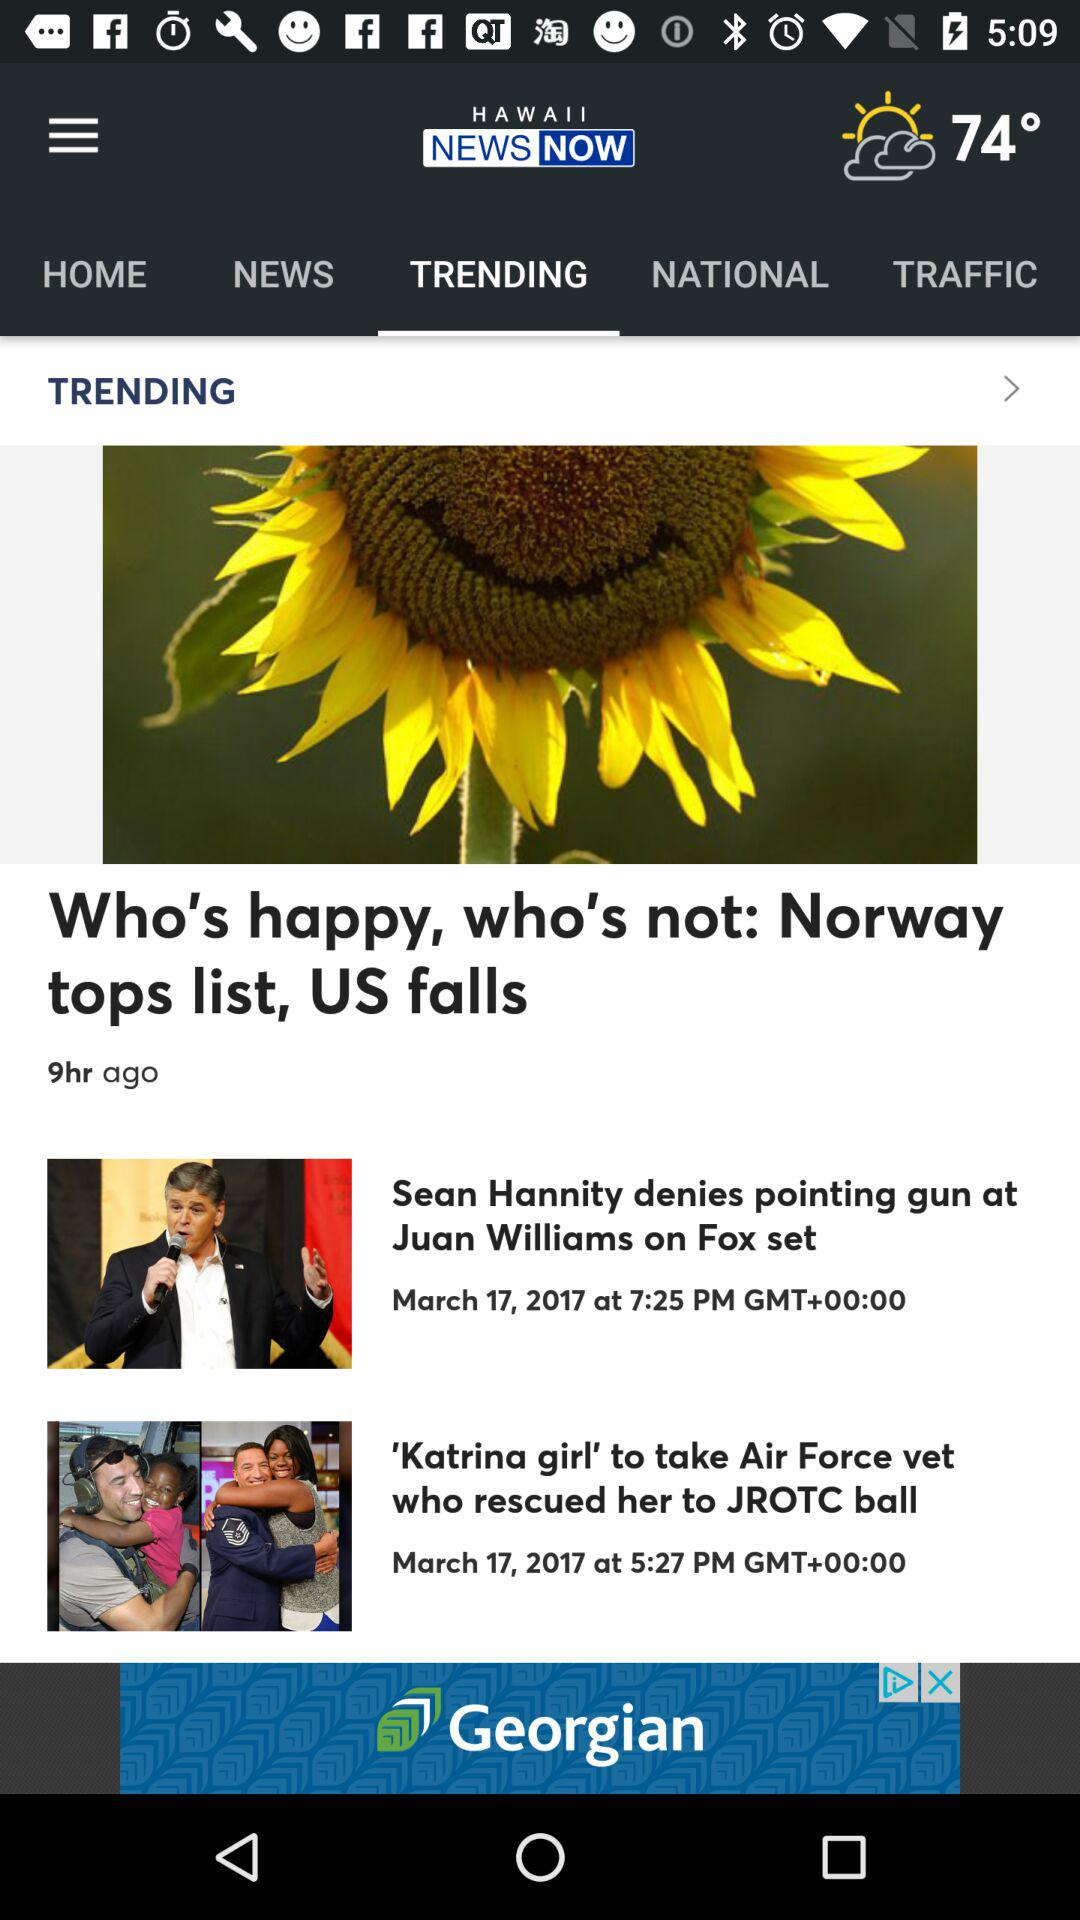When was the news " Who's happy, who's not: Norway tops list, US falls" posted? It was posted 9 hours ago. 